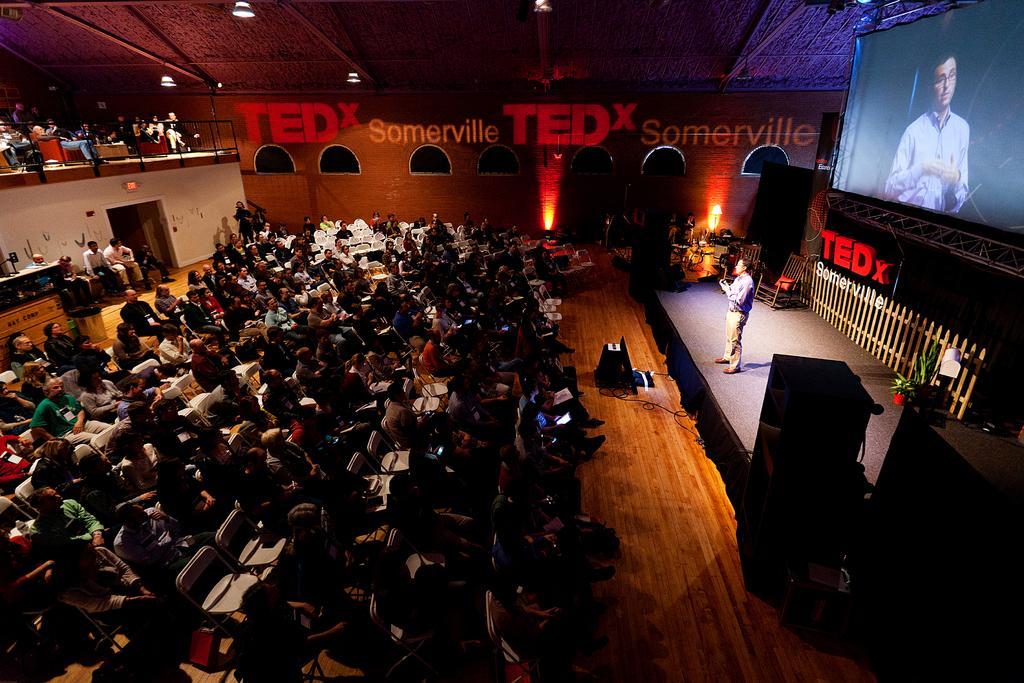Describe this image in one or two sentences. In the picture we can see a hall with some public sitting on the chairs and a man standing on the chair and giving a speech and behind him we can see a wall with a railing and top of it, we can see a screen with an image of a person and in the background we can see a wall with a name on it TEDx Somerville and to the ceiling we can see some lights. 